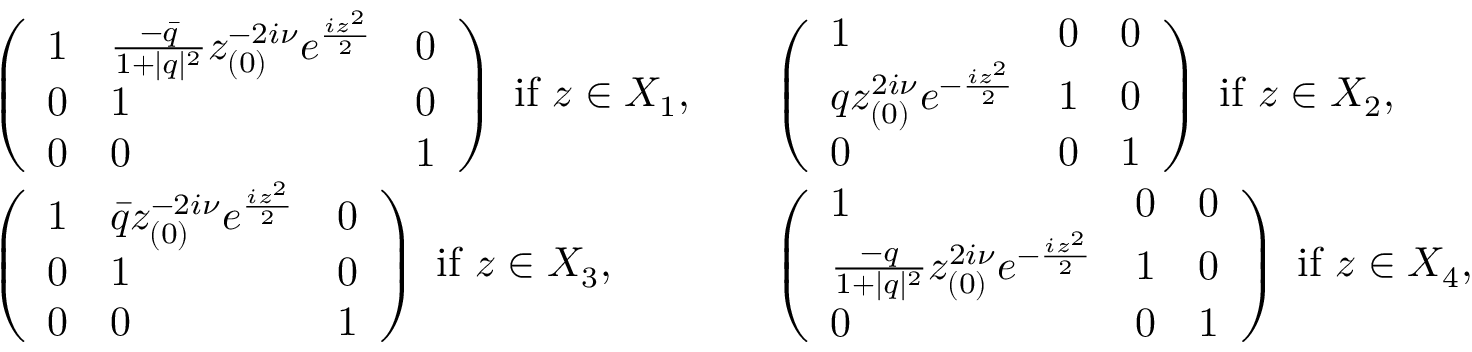<formula> <loc_0><loc_0><loc_500><loc_500>\begin{array} { r l r l } & { \left ( \begin{array} { l l l } { 1 } & { \frac { - \bar { q } } { 1 + | q | ^ { 2 } } z _ { ( 0 ) } ^ { - 2 i \nu } e ^ { \frac { i z ^ { 2 } } { 2 } } } & { 0 } \\ { 0 } & { 1 } & { 0 } \\ { 0 } & { 0 } & { 1 } \end{array} \right ) i f z \in X _ { 1 } , } & & { \left ( \begin{array} { l l l } { 1 } & { 0 } & { 0 } \\ { q z _ { ( 0 ) } ^ { 2 i \nu } e ^ { - \frac { i z ^ { 2 } } { 2 } } } & { 1 } & { 0 } \\ { 0 } & { 0 } & { 1 } \end{array} \right ) i f z \in X _ { 2 } , } \\ & { \left ( \begin{array} { l l l } { 1 } & { \bar { q } z _ { ( 0 ) } ^ { - 2 i \nu } e ^ { \frac { i z ^ { 2 } } { 2 } } } & { 0 } \\ { 0 } & { 1 } & { 0 } \\ { 0 } & { 0 } & { 1 } \end{array} \right ) i f z \in X _ { 3 } , } & & { \left ( \begin{array} { l l l } { 1 } & { 0 } & { 0 } \\ { \frac { - q } { 1 + | q | ^ { 2 } } z _ { ( 0 ) } ^ { 2 i \nu } e ^ { - \frac { i z ^ { 2 } } { 2 } } } & { 1 } & { 0 } \\ { 0 } & { 0 } & { 1 } \end{array} \right ) i f z \in X _ { 4 } , } \end{array}</formula> 